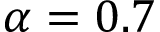<formula> <loc_0><loc_0><loc_500><loc_500>\alpha = 0 . 7</formula> 